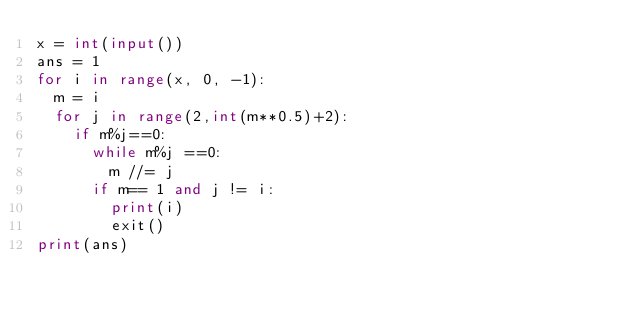<code> <loc_0><loc_0><loc_500><loc_500><_Python_>x = int(input())
ans = 1
for i in range(x, 0, -1):
  m = i
  for j in range(2,int(m**0.5)+2):
    if m%j==0:
      while m%j ==0:
        m //= j
      if m== 1 and j != i:
        print(i)
        exit()
print(ans)

</code> 